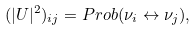Convert formula to latex. <formula><loc_0><loc_0><loc_500><loc_500>( | U | ^ { 2 } ) _ { i j } = P r o b ( \nu _ { i } \leftrightarrow \nu _ { j } ) ,</formula> 